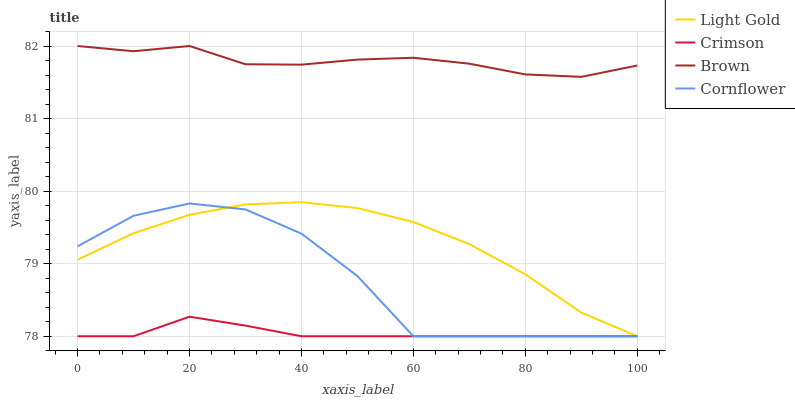Does Crimson have the minimum area under the curve?
Answer yes or no. Yes. Does Brown have the maximum area under the curve?
Answer yes or no. Yes. Does Light Gold have the minimum area under the curve?
Answer yes or no. No. Does Light Gold have the maximum area under the curve?
Answer yes or no. No. Is Crimson the smoothest?
Answer yes or no. Yes. Is Cornflower the roughest?
Answer yes or no. Yes. Is Brown the smoothest?
Answer yes or no. No. Is Brown the roughest?
Answer yes or no. No. Does Crimson have the lowest value?
Answer yes or no. Yes. Does Brown have the lowest value?
Answer yes or no. No. Does Brown have the highest value?
Answer yes or no. Yes. Does Light Gold have the highest value?
Answer yes or no. No. Is Crimson less than Brown?
Answer yes or no. Yes. Is Brown greater than Cornflower?
Answer yes or no. Yes. Does Cornflower intersect Crimson?
Answer yes or no. Yes. Is Cornflower less than Crimson?
Answer yes or no. No. Is Cornflower greater than Crimson?
Answer yes or no. No. Does Crimson intersect Brown?
Answer yes or no. No. 